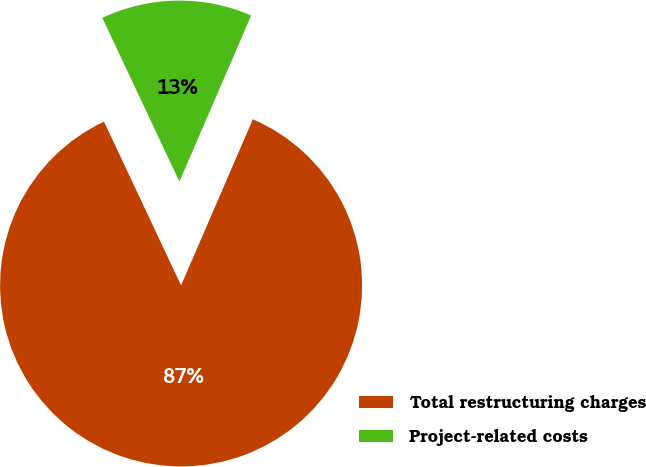Convert chart to OTSL. <chart><loc_0><loc_0><loc_500><loc_500><pie_chart><fcel>Total restructuring charges<fcel>Project-related costs<nl><fcel>86.51%<fcel>13.49%<nl></chart> 